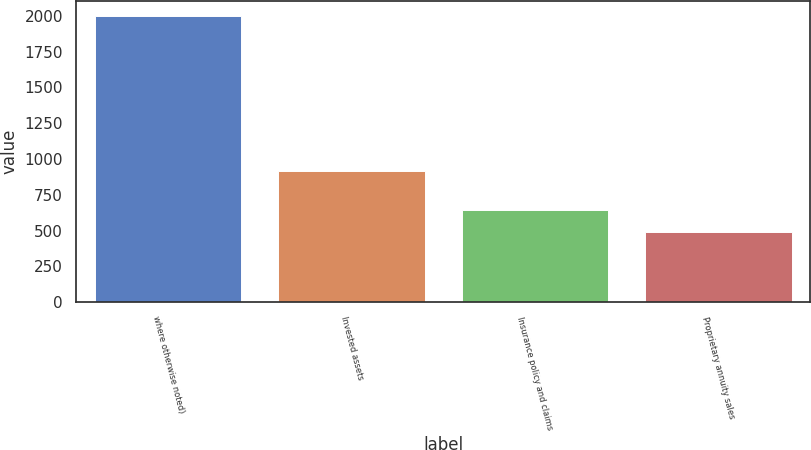<chart> <loc_0><loc_0><loc_500><loc_500><bar_chart><fcel>where otherwise noted)<fcel>Invested assets<fcel>Insurance policy and claims<fcel>Proprietary annuity sales<nl><fcel>2002<fcel>919<fcel>641.2<fcel>490<nl></chart> 